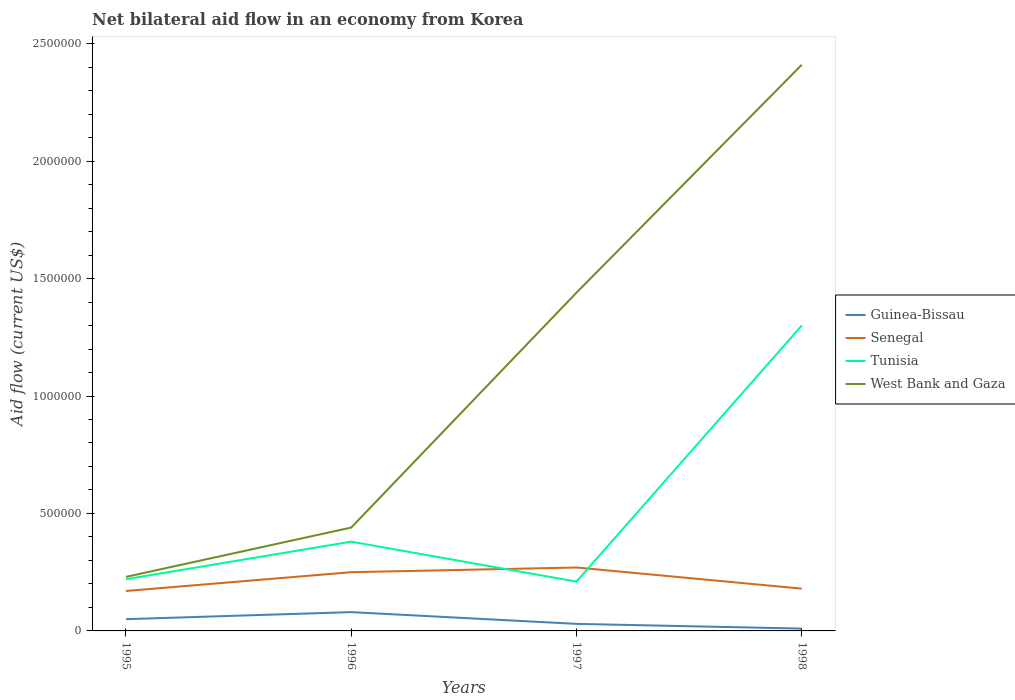How many different coloured lines are there?
Your answer should be compact. 4. Does the line corresponding to Tunisia intersect with the line corresponding to Senegal?
Your answer should be compact. Yes. Across all years, what is the maximum net bilateral aid flow in Tunisia?
Your response must be concise. 2.10e+05. In which year was the net bilateral aid flow in Senegal maximum?
Provide a succinct answer. 1995. What is the total net bilateral aid flow in Tunisia in the graph?
Ensure brevity in your answer.  -1.60e+05. What is the difference between the highest and the second highest net bilateral aid flow in West Bank and Gaza?
Your answer should be compact. 2.18e+06. What is the difference between the highest and the lowest net bilateral aid flow in Senegal?
Provide a succinct answer. 2. Is the net bilateral aid flow in West Bank and Gaza strictly greater than the net bilateral aid flow in Tunisia over the years?
Your answer should be compact. No. What is the difference between two consecutive major ticks on the Y-axis?
Make the answer very short. 5.00e+05. How many legend labels are there?
Ensure brevity in your answer.  4. How are the legend labels stacked?
Ensure brevity in your answer.  Vertical. What is the title of the graph?
Provide a succinct answer. Net bilateral aid flow in an economy from Korea. What is the label or title of the X-axis?
Ensure brevity in your answer.  Years. What is the label or title of the Y-axis?
Make the answer very short. Aid flow (current US$). What is the Aid flow (current US$) in Senegal in 1995?
Offer a terse response. 1.70e+05. What is the Aid flow (current US$) of Tunisia in 1995?
Your answer should be compact. 2.20e+05. What is the Aid flow (current US$) of Guinea-Bissau in 1996?
Offer a terse response. 8.00e+04. What is the Aid flow (current US$) of Guinea-Bissau in 1997?
Your answer should be compact. 3.00e+04. What is the Aid flow (current US$) of Senegal in 1997?
Keep it short and to the point. 2.70e+05. What is the Aid flow (current US$) of Tunisia in 1997?
Provide a succinct answer. 2.10e+05. What is the Aid flow (current US$) in West Bank and Gaza in 1997?
Your answer should be very brief. 1.44e+06. What is the Aid flow (current US$) of Guinea-Bissau in 1998?
Keep it short and to the point. 10000. What is the Aid flow (current US$) of Tunisia in 1998?
Provide a short and direct response. 1.30e+06. What is the Aid flow (current US$) of West Bank and Gaza in 1998?
Your answer should be very brief. 2.41e+06. Across all years, what is the maximum Aid flow (current US$) in Senegal?
Offer a very short reply. 2.70e+05. Across all years, what is the maximum Aid flow (current US$) in Tunisia?
Offer a very short reply. 1.30e+06. Across all years, what is the maximum Aid flow (current US$) of West Bank and Gaza?
Your answer should be very brief. 2.41e+06. Across all years, what is the minimum Aid flow (current US$) in Guinea-Bissau?
Your answer should be very brief. 10000. Across all years, what is the minimum Aid flow (current US$) of Tunisia?
Provide a succinct answer. 2.10e+05. Across all years, what is the minimum Aid flow (current US$) in West Bank and Gaza?
Ensure brevity in your answer.  2.30e+05. What is the total Aid flow (current US$) in Guinea-Bissau in the graph?
Provide a succinct answer. 1.70e+05. What is the total Aid flow (current US$) in Senegal in the graph?
Your answer should be very brief. 8.70e+05. What is the total Aid flow (current US$) in Tunisia in the graph?
Your response must be concise. 2.11e+06. What is the total Aid flow (current US$) in West Bank and Gaza in the graph?
Provide a short and direct response. 4.52e+06. What is the difference between the Aid flow (current US$) in Guinea-Bissau in 1995 and that in 1996?
Provide a short and direct response. -3.00e+04. What is the difference between the Aid flow (current US$) in West Bank and Gaza in 1995 and that in 1996?
Offer a very short reply. -2.10e+05. What is the difference between the Aid flow (current US$) of West Bank and Gaza in 1995 and that in 1997?
Offer a very short reply. -1.21e+06. What is the difference between the Aid flow (current US$) of Guinea-Bissau in 1995 and that in 1998?
Your answer should be compact. 4.00e+04. What is the difference between the Aid flow (current US$) of Senegal in 1995 and that in 1998?
Your answer should be compact. -10000. What is the difference between the Aid flow (current US$) of Tunisia in 1995 and that in 1998?
Offer a very short reply. -1.08e+06. What is the difference between the Aid flow (current US$) in West Bank and Gaza in 1995 and that in 1998?
Ensure brevity in your answer.  -2.18e+06. What is the difference between the Aid flow (current US$) of Tunisia in 1996 and that in 1997?
Make the answer very short. 1.70e+05. What is the difference between the Aid flow (current US$) of West Bank and Gaza in 1996 and that in 1997?
Your answer should be very brief. -1.00e+06. What is the difference between the Aid flow (current US$) in Guinea-Bissau in 1996 and that in 1998?
Offer a very short reply. 7.00e+04. What is the difference between the Aid flow (current US$) in Senegal in 1996 and that in 1998?
Keep it short and to the point. 7.00e+04. What is the difference between the Aid flow (current US$) of Tunisia in 1996 and that in 1998?
Make the answer very short. -9.20e+05. What is the difference between the Aid flow (current US$) of West Bank and Gaza in 1996 and that in 1998?
Offer a terse response. -1.97e+06. What is the difference between the Aid flow (current US$) in Guinea-Bissau in 1997 and that in 1998?
Offer a terse response. 2.00e+04. What is the difference between the Aid flow (current US$) in Tunisia in 1997 and that in 1998?
Your answer should be compact. -1.09e+06. What is the difference between the Aid flow (current US$) of West Bank and Gaza in 1997 and that in 1998?
Offer a very short reply. -9.70e+05. What is the difference between the Aid flow (current US$) of Guinea-Bissau in 1995 and the Aid flow (current US$) of Tunisia in 1996?
Your response must be concise. -3.30e+05. What is the difference between the Aid flow (current US$) in Guinea-Bissau in 1995 and the Aid flow (current US$) in West Bank and Gaza in 1996?
Offer a terse response. -3.90e+05. What is the difference between the Aid flow (current US$) of Senegal in 1995 and the Aid flow (current US$) of Tunisia in 1996?
Provide a succinct answer. -2.10e+05. What is the difference between the Aid flow (current US$) in Senegal in 1995 and the Aid flow (current US$) in West Bank and Gaza in 1996?
Offer a terse response. -2.70e+05. What is the difference between the Aid flow (current US$) of Guinea-Bissau in 1995 and the Aid flow (current US$) of Senegal in 1997?
Keep it short and to the point. -2.20e+05. What is the difference between the Aid flow (current US$) in Guinea-Bissau in 1995 and the Aid flow (current US$) in Tunisia in 1997?
Provide a short and direct response. -1.60e+05. What is the difference between the Aid flow (current US$) in Guinea-Bissau in 1995 and the Aid flow (current US$) in West Bank and Gaza in 1997?
Offer a very short reply. -1.39e+06. What is the difference between the Aid flow (current US$) in Senegal in 1995 and the Aid flow (current US$) in West Bank and Gaza in 1997?
Ensure brevity in your answer.  -1.27e+06. What is the difference between the Aid flow (current US$) in Tunisia in 1995 and the Aid flow (current US$) in West Bank and Gaza in 1997?
Give a very brief answer. -1.22e+06. What is the difference between the Aid flow (current US$) of Guinea-Bissau in 1995 and the Aid flow (current US$) of Senegal in 1998?
Make the answer very short. -1.30e+05. What is the difference between the Aid flow (current US$) in Guinea-Bissau in 1995 and the Aid flow (current US$) in Tunisia in 1998?
Keep it short and to the point. -1.25e+06. What is the difference between the Aid flow (current US$) of Guinea-Bissau in 1995 and the Aid flow (current US$) of West Bank and Gaza in 1998?
Give a very brief answer. -2.36e+06. What is the difference between the Aid flow (current US$) of Senegal in 1995 and the Aid flow (current US$) of Tunisia in 1998?
Give a very brief answer. -1.13e+06. What is the difference between the Aid flow (current US$) of Senegal in 1995 and the Aid flow (current US$) of West Bank and Gaza in 1998?
Provide a succinct answer. -2.24e+06. What is the difference between the Aid flow (current US$) in Tunisia in 1995 and the Aid flow (current US$) in West Bank and Gaza in 1998?
Ensure brevity in your answer.  -2.19e+06. What is the difference between the Aid flow (current US$) of Guinea-Bissau in 1996 and the Aid flow (current US$) of Tunisia in 1997?
Your answer should be compact. -1.30e+05. What is the difference between the Aid flow (current US$) of Guinea-Bissau in 1996 and the Aid flow (current US$) of West Bank and Gaza in 1997?
Give a very brief answer. -1.36e+06. What is the difference between the Aid flow (current US$) of Senegal in 1996 and the Aid flow (current US$) of West Bank and Gaza in 1997?
Ensure brevity in your answer.  -1.19e+06. What is the difference between the Aid flow (current US$) in Tunisia in 1996 and the Aid flow (current US$) in West Bank and Gaza in 1997?
Your response must be concise. -1.06e+06. What is the difference between the Aid flow (current US$) in Guinea-Bissau in 1996 and the Aid flow (current US$) in Tunisia in 1998?
Your answer should be compact. -1.22e+06. What is the difference between the Aid flow (current US$) of Guinea-Bissau in 1996 and the Aid flow (current US$) of West Bank and Gaza in 1998?
Your answer should be compact. -2.33e+06. What is the difference between the Aid flow (current US$) of Senegal in 1996 and the Aid flow (current US$) of Tunisia in 1998?
Ensure brevity in your answer.  -1.05e+06. What is the difference between the Aid flow (current US$) in Senegal in 1996 and the Aid flow (current US$) in West Bank and Gaza in 1998?
Keep it short and to the point. -2.16e+06. What is the difference between the Aid flow (current US$) in Tunisia in 1996 and the Aid flow (current US$) in West Bank and Gaza in 1998?
Ensure brevity in your answer.  -2.03e+06. What is the difference between the Aid flow (current US$) of Guinea-Bissau in 1997 and the Aid flow (current US$) of Tunisia in 1998?
Ensure brevity in your answer.  -1.27e+06. What is the difference between the Aid flow (current US$) in Guinea-Bissau in 1997 and the Aid flow (current US$) in West Bank and Gaza in 1998?
Provide a short and direct response. -2.38e+06. What is the difference between the Aid flow (current US$) in Senegal in 1997 and the Aid flow (current US$) in Tunisia in 1998?
Make the answer very short. -1.03e+06. What is the difference between the Aid flow (current US$) of Senegal in 1997 and the Aid flow (current US$) of West Bank and Gaza in 1998?
Provide a succinct answer. -2.14e+06. What is the difference between the Aid flow (current US$) in Tunisia in 1997 and the Aid flow (current US$) in West Bank and Gaza in 1998?
Provide a short and direct response. -2.20e+06. What is the average Aid flow (current US$) of Guinea-Bissau per year?
Your response must be concise. 4.25e+04. What is the average Aid flow (current US$) of Senegal per year?
Offer a very short reply. 2.18e+05. What is the average Aid flow (current US$) in Tunisia per year?
Your answer should be compact. 5.28e+05. What is the average Aid flow (current US$) in West Bank and Gaza per year?
Your answer should be compact. 1.13e+06. In the year 1995, what is the difference between the Aid flow (current US$) in Guinea-Bissau and Aid flow (current US$) in Tunisia?
Give a very brief answer. -1.70e+05. In the year 1996, what is the difference between the Aid flow (current US$) in Guinea-Bissau and Aid flow (current US$) in Tunisia?
Your answer should be compact. -3.00e+05. In the year 1996, what is the difference between the Aid flow (current US$) of Guinea-Bissau and Aid flow (current US$) of West Bank and Gaza?
Provide a short and direct response. -3.60e+05. In the year 1996, what is the difference between the Aid flow (current US$) of Tunisia and Aid flow (current US$) of West Bank and Gaza?
Offer a very short reply. -6.00e+04. In the year 1997, what is the difference between the Aid flow (current US$) in Guinea-Bissau and Aid flow (current US$) in West Bank and Gaza?
Your answer should be very brief. -1.41e+06. In the year 1997, what is the difference between the Aid flow (current US$) in Senegal and Aid flow (current US$) in West Bank and Gaza?
Your response must be concise. -1.17e+06. In the year 1997, what is the difference between the Aid flow (current US$) in Tunisia and Aid flow (current US$) in West Bank and Gaza?
Ensure brevity in your answer.  -1.23e+06. In the year 1998, what is the difference between the Aid flow (current US$) of Guinea-Bissau and Aid flow (current US$) of Tunisia?
Keep it short and to the point. -1.29e+06. In the year 1998, what is the difference between the Aid flow (current US$) of Guinea-Bissau and Aid flow (current US$) of West Bank and Gaza?
Your answer should be compact. -2.40e+06. In the year 1998, what is the difference between the Aid flow (current US$) of Senegal and Aid flow (current US$) of Tunisia?
Provide a succinct answer. -1.12e+06. In the year 1998, what is the difference between the Aid flow (current US$) of Senegal and Aid flow (current US$) of West Bank and Gaza?
Provide a succinct answer. -2.23e+06. In the year 1998, what is the difference between the Aid flow (current US$) of Tunisia and Aid flow (current US$) of West Bank and Gaza?
Give a very brief answer. -1.11e+06. What is the ratio of the Aid flow (current US$) in Senegal in 1995 to that in 1996?
Ensure brevity in your answer.  0.68. What is the ratio of the Aid flow (current US$) in Tunisia in 1995 to that in 1996?
Keep it short and to the point. 0.58. What is the ratio of the Aid flow (current US$) of West Bank and Gaza in 1995 to that in 1996?
Your answer should be very brief. 0.52. What is the ratio of the Aid flow (current US$) in Guinea-Bissau in 1995 to that in 1997?
Your answer should be compact. 1.67. What is the ratio of the Aid flow (current US$) of Senegal in 1995 to that in 1997?
Ensure brevity in your answer.  0.63. What is the ratio of the Aid flow (current US$) of Tunisia in 1995 to that in 1997?
Ensure brevity in your answer.  1.05. What is the ratio of the Aid flow (current US$) in West Bank and Gaza in 1995 to that in 1997?
Provide a succinct answer. 0.16. What is the ratio of the Aid flow (current US$) in Senegal in 1995 to that in 1998?
Your response must be concise. 0.94. What is the ratio of the Aid flow (current US$) of Tunisia in 1995 to that in 1998?
Provide a short and direct response. 0.17. What is the ratio of the Aid flow (current US$) of West Bank and Gaza in 1995 to that in 1998?
Provide a succinct answer. 0.1. What is the ratio of the Aid flow (current US$) of Guinea-Bissau in 1996 to that in 1997?
Offer a very short reply. 2.67. What is the ratio of the Aid flow (current US$) in Senegal in 1996 to that in 1997?
Offer a very short reply. 0.93. What is the ratio of the Aid flow (current US$) in Tunisia in 1996 to that in 1997?
Your response must be concise. 1.81. What is the ratio of the Aid flow (current US$) in West Bank and Gaza in 1996 to that in 1997?
Give a very brief answer. 0.31. What is the ratio of the Aid flow (current US$) of Guinea-Bissau in 1996 to that in 1998?
Provide a short and direct response. 8. What is the ratio of the Aid flow (current US$) of Senegal in 1996 to that in 1998?
Offer a very short reply. 1.39. What is the ratio of the Aid flow (current US$) of Tunisia in 1996 to that in 1998?
Give a very brief answer. 0.29. What is the ratio of the Aid flow (current US$) of West Bank and Gaza in 1996 to that in 1998?
Your answer should be compact. 0.18. What is the ratio of the Aid flow (current US$) of Guinea-Bissau in 1997 to that in 1998?
Provide a succinct answer. 3. What is the ratio of the Aid flow (current US$) of Senegal in 1997 to that in 1998?
Provide a succinct answer. 1.5. What is the ratio of the Aid flow (current US$) of Tunisia in 1997 to that in 1998?
Provide a succinct answer. 0.16. What is the ratio of the Aid flow (current US$) in West Bank and Gaza in 1997 to that in 1998?
Your answer should be very brief. 0.6. What is the difference between the highest and the second highest Aid flow (current US$) of Tunisia?
Offer a very short reply. 9.20e+05. What is the difference between the highest and the second highest Aid flow (current US$) of West Bank and Gaza?
Offer a very short reply. 9.70e+05. What is the difference between the highest and the lowest Aid flow (current US$) in Senegal?
Make the answer very short. 1.00e+05. What is the difference between the highest and the lowest Aid flow (current US$) of Tunisia?
Your response must be concise. 1.09e+06. What is the difference between the highest and the lowest Aid flow (current US$) in West Bank and Gaza?
Your response must be concise. 2.18e+06. 